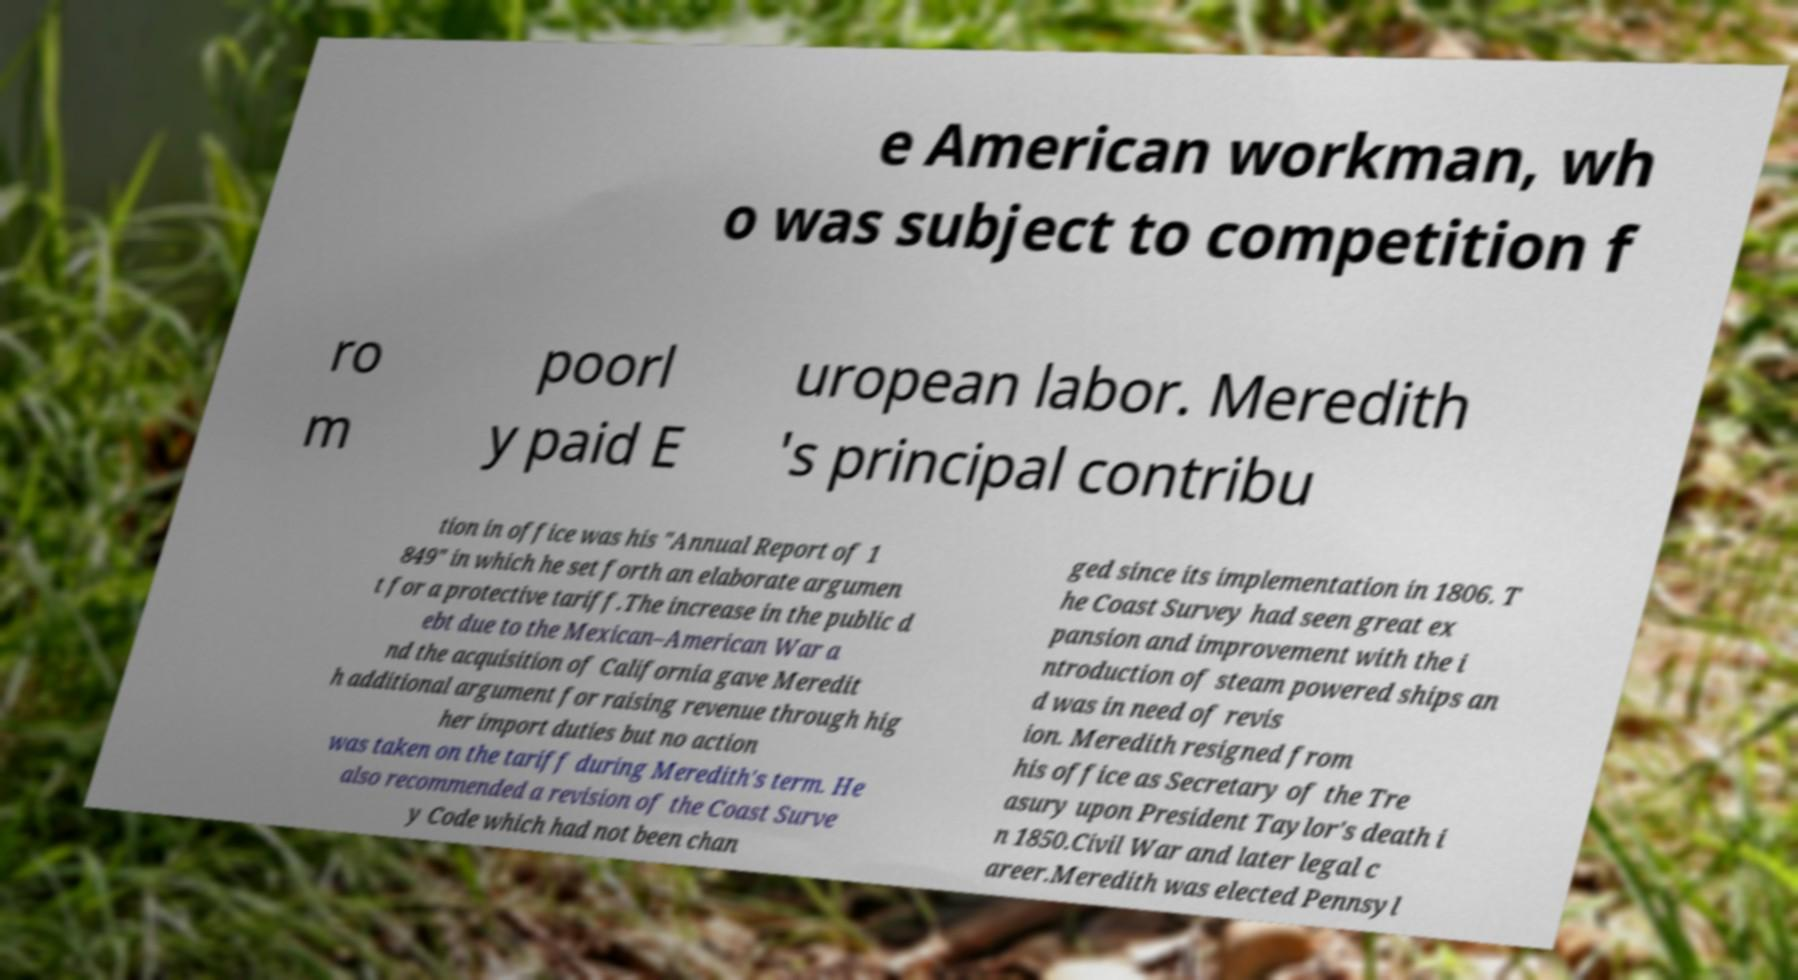Could you assist in decoding the text presented in this image and type it out clearly? e American workman, wh o was subject to competition f ro m poorl y paid E uropean labor. Meredith 's principal contribu tion in office was his "Annual Report of 1 849" in which he set forth an elaborate argumen t for a protective tariff.The increase in the public d ebt due to the Mexican–American War a nd the acquisition of California gave Meredit h additional argument for raising revenue through hig her import duties but no action was taken on the tariff during Meredith's term. He also recommended a revision of the Coast Surve y Code which had not been chan ged since its implementation in 1806. T he Coast Survey had seen great ex pansion and improvement with the i ntroduction of steam powered ships an d was in need of revis ion. Meredith resigned from his office as Secretary of the Tre asury upon President Taylor's death i n 1850.Civil War and later legal c areer.Meredith was elected Pennsyl 